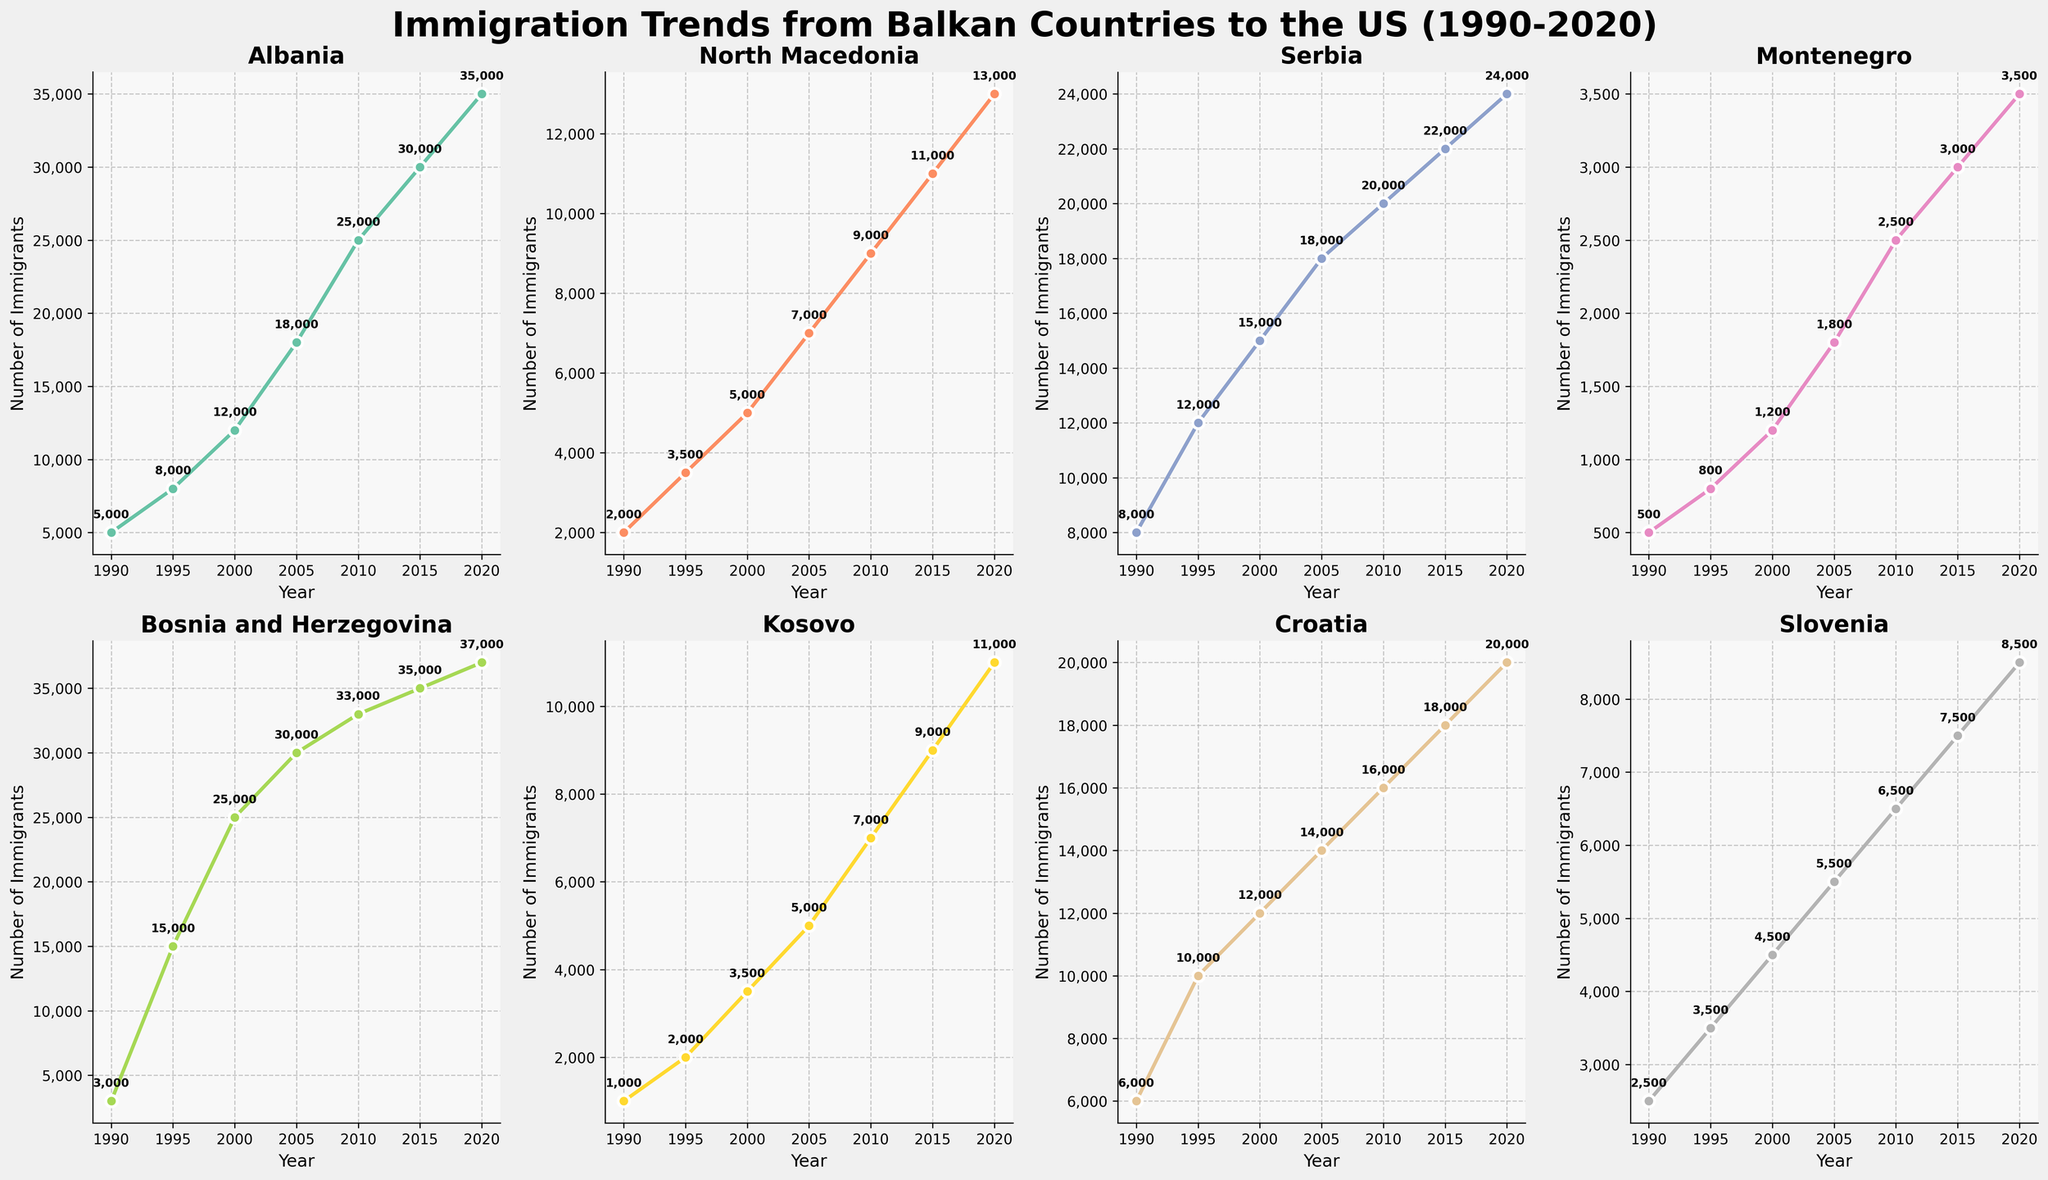What's the country with the highest number of immigrants to the US in 2020? Look at the plot for the year 2020 and identify which country has the highest point on the y-axis. Bosnia and Herzegovina has the most immigrants with 37,000.
Answer: Bosnia and Herzegovina How did the number of immigrants from Kosovo change from 1990 to 2020? Compare the immigrant values for Kosovo for the years 1990 and 2020. The number of immigrants increased from 1,000 in 1990 to 11,000 in 2020.
Answer: Increased by 10,000 Which country had the least immigrants in 2005? Examine the subplots for the year 2005 and identify which country has the lowest point. Montenegro had the least number of immigrants in 2005 with 1,800 immigrants.
Answer: Montenegro What's the total number of immigrants from Albania and Serbia in 2010? Add the number of immigrants from Albania and Serbia for the year 2010. Albania had 25,000 and Serbia had 20,000, so the total is 25,000 + 20,000 = 45,000.
Answer: 45,000 Compare the trends of North Macedonia and Croatia from 1990 to 2020. Who saw a larger increase? Look at the plot lines for North Macedonia and Croatia from 1990 to 2020. North Macedonia increased from 2,000 to 13,000, while Croatia increased from 6,000 to 20,000. North Macedonia saw an increase of 11,000 and Croatia 14,000.
Answer: Croatia Which country's immigration numbers showed a continuously increasing trend from 1990 to 2020? Check each subplot to see which country's immigrant numbers increase every year from 1990 to 2020. Bosnia and Herzegovina shows a continuously increasing trend.
Answer: Bosnia and Herzegovina What's the average number of immigrants from Montenegro over the years 1990, 2000, and 2010? Add up the number of immigrants from Montenegro for the years 1990, 2000, and 2010, then divide by 3. The numbers are 500, 1,200, and 2,500. So, (500 + 1,200 + 2,500) / 3 = 1,400.
Answer: 1,400 